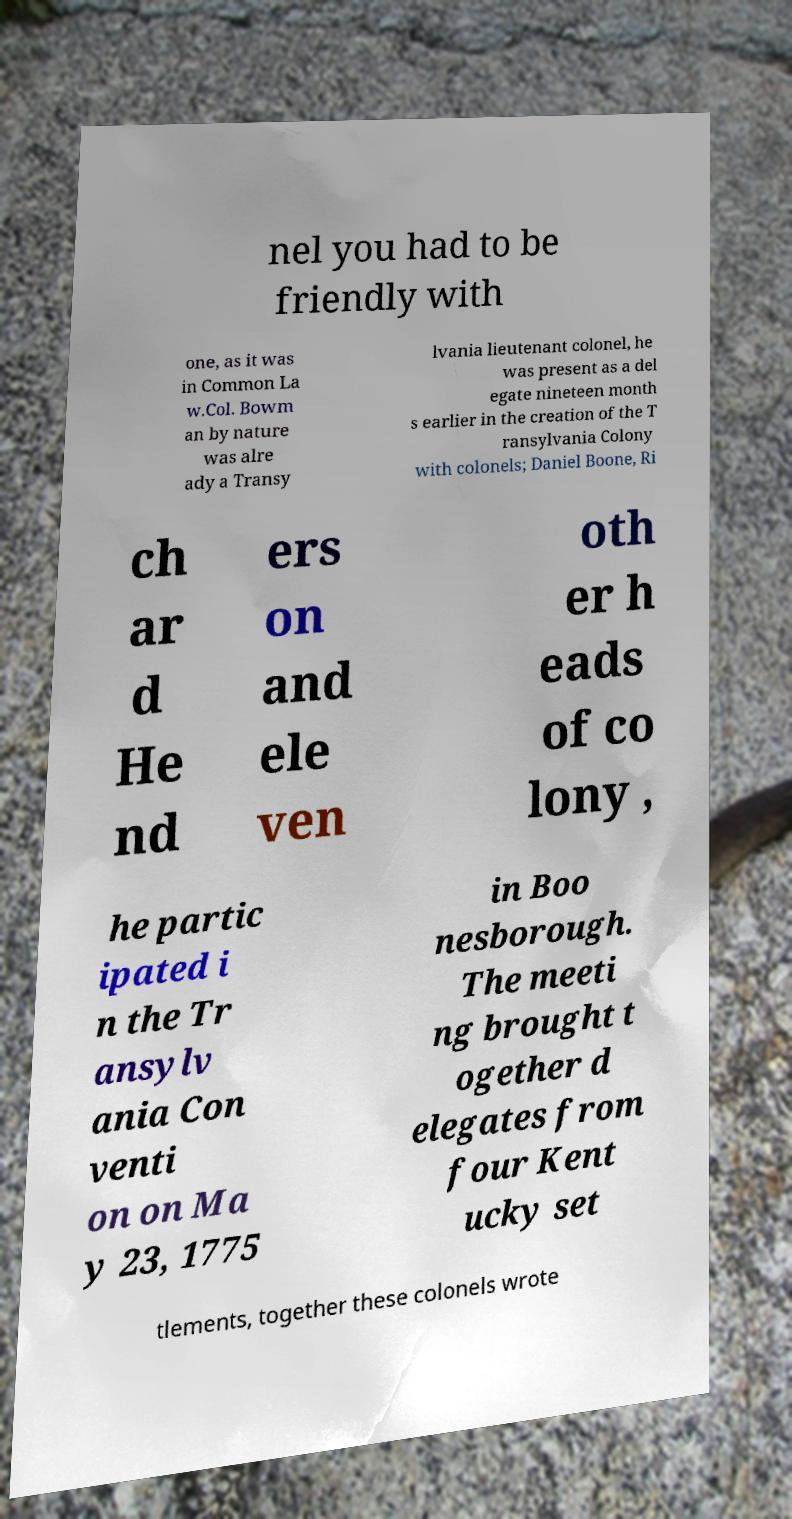What messages or text are displayed in this image? I need them in a readable, typed format. nel you had to be friendly with one, as it was in Common La w.Col. Bowm an by nature was alre ady a Transy lvania lieutenant colonel, he was present as a del egate nineteen month s earlier in the creation of the T ransylvania Colony with colonels; Daniel Boone, Ri ch ar d He nd ers on and ele ven oth er h eads of co lony , he partic ipated i n the Tr ansylv ania Con venti on on Ma y 23, 1775 in Boo nesborough. The meeti ng brought t ogether d elegates from four Kent ucky set tlements, together these colonels wrote 